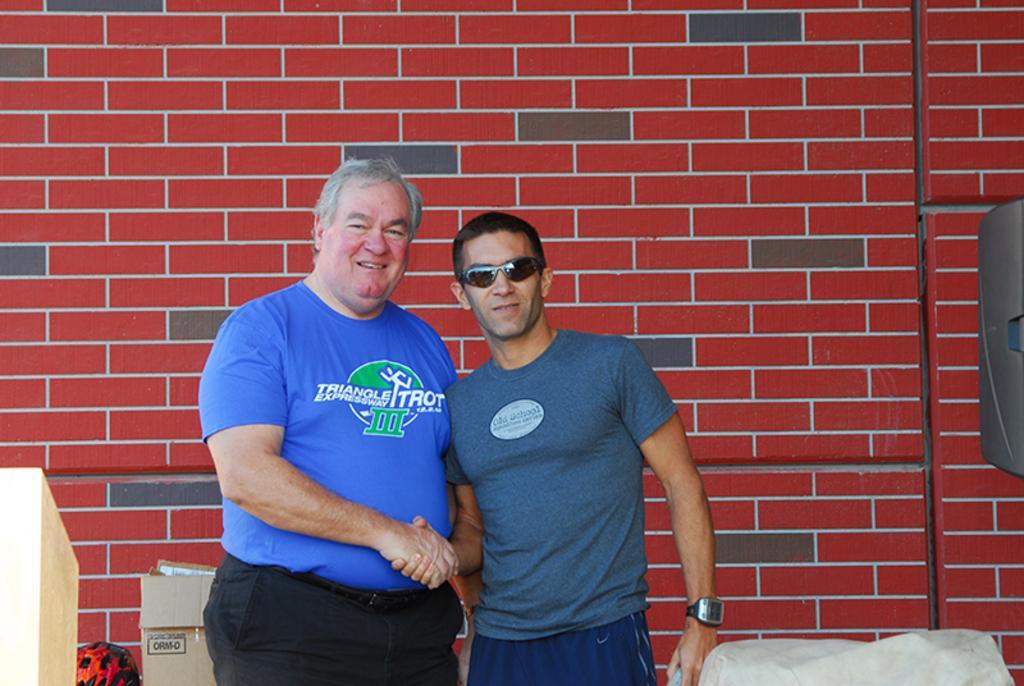Please provide a concise description of this image. Here we can see two men and he has goggles. There is a box. In the background we can see a wall. 